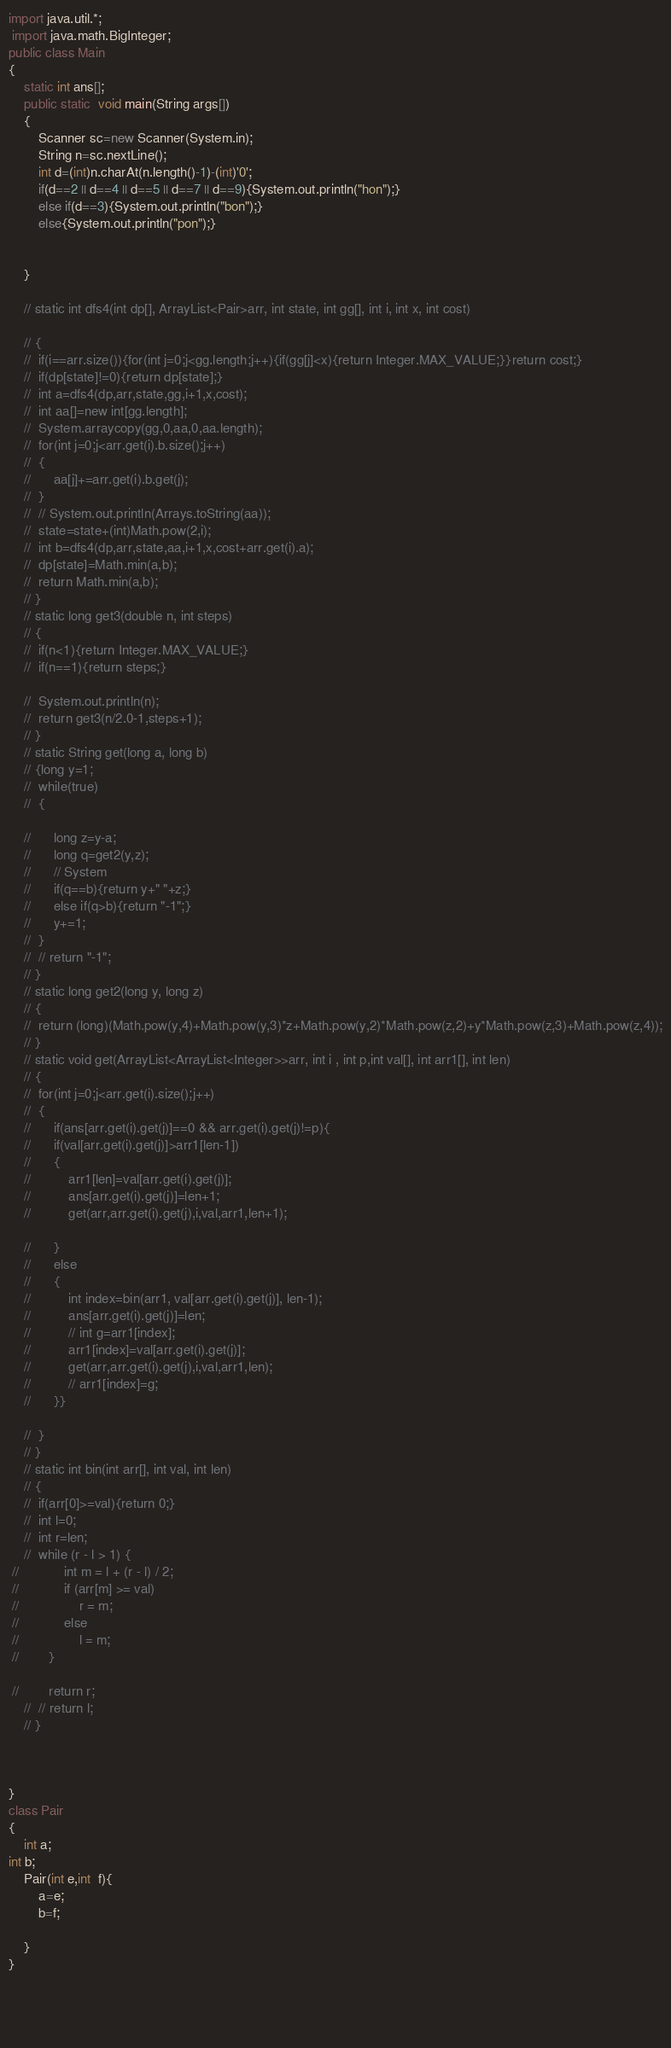<code> <loc_0><loc_0><loc_500><loc_500><_Java_>import java.util.*;
 import java.math.BigInteger;
public class Main
{
	static int ans[];
	public static  void main(String args[])
	{
		Scanner sc=new Scanner(System.in);
		String n=sc.nextLine();
		int d=(int)n.charAt(n.length()-1)-(int)'0';
		if(d==2 || d==4 || d==5 || d==7 || d==9){System.out.println("hon");}
		else if(d==3){System.out.println("bon");}
		else{System.out.println("pon");}
		

	}
	
	// static int dfs4(int dp[], ArrayList<Pair>arr, int state, int gg[], int i, int x, int cost)

	// {
	// 	if(i==arr.size()){for(int j=0;j<gg.length;j++){if(gg[j]<x){return Integer.MAX_VALUE;}}return cost;}
	// 	if(dp[state]!=0){return dp[state];}
	// 	int a=dfs4(dp,arr,state,gg,i+1,x,cost);
	// 	int aa[]=new int[gg.length];
	// 	System.arraycopy(gg,0,aa,0,aa.length);
	// 	for(int j=0;j<arr.get(i).b.size();j++)
	// 	{
	// 		aa[j]+=arr.get(i).b.get(j);
	// 	}
	// 	// System.out.println(Arrays.toString(aa));
	// 	state=state+(int)Math.pow(2,i);
	// 	int b=dfs4(dp,arr,state,aa,i+1,x,cost+arr.get(i).a);
	// 	dp[state]=Math.min(a,b);
	// 	return Math.min(a,b);
	// }
	// static long get3(double n, int steps)
	// {
	// 	if(n<1){return Integer.MAX_VALUE;}
	// 	if(n==1){return steps;}

	// 	System.out.println(n);
	// 	return get3(n/2.0-1,steps+1);
	// }
	// static String get(long a, long b)
	// {long y=1;
	// 	while(true)
	// 	{

	// 		long z=y-a;
	// 		long q=get2(y,z);
	// 		// System
	// 		if(q==b){return y+" "+z;}
	// 		else if(q>b){return "-1";}
	// 		y+=1;
	// 	}
	// 	// return "-1";
	// }
	// static long get2(long y, long z)
	// {
	// 	return (long)(Math.pow(y,4)+Math.pow(y,3)*z+Math.pow(y,2)*Math.pow(z,2)+y*Math.pow(z,3)+Math.pow(z,4));
	// }
	// static void get(ArrayList<ArrayList<Integer>>arr, int i , int p,int val[], int arr1[], int len)
	// {
	// 	for(int j=0;j<arr.get(i).size();j++)
	// 	{
	// 		if(ans[arr.get(i).get(j)]==0 && arr.get(i).get(j)!=p){
	// 		if(val[arr.get(i).get(j)]>arr1[len-1])
	// 		{
	// 			arr1[len]=val[arr.get(i).get(j)];
	// 			ans[arr.get(i).get(j)]=len+1;
	// 			get(arr,arr.get(i).get(j),i,val,arr1,len+1);
				
	// 		}
	// 		else
	// 		{
	// 			int index=bin(arr1, val[arr.get(i).get(j)], len-1);
	// 			ans[arr.get(i).get(j)]=len;
	// 			// int g=arr1[index];
	// 			arr1[index]=val[arr.get(i).get(j)];
	// 			get(arr,arr.get(i).get(j),i,val,arr1,len);
	// 			// arr1[index]=g;
	// 		}}

	// 	}
	// }
	// static int bin(int arr[], int val, int len)
	// {
	// 	if(arr[0]>=val){return 0;}
	// 	int l=0;
	// 	int r=len;
	// 	while (r - l > 1) { 
 //            int m = l + (r - l) / 2; 
 //            if (arr[m] >= val) 
 //                r = m; 
 //            else
 //                l = m; 
 //        } 
  
 //        return r; 
	// 	// return l;
	// }
	
	

}
class Pair
{
	int a;
int b;
	Pair(int e,int  f){
		a=e;
		b=f;
		
	}
}



	
</code> 